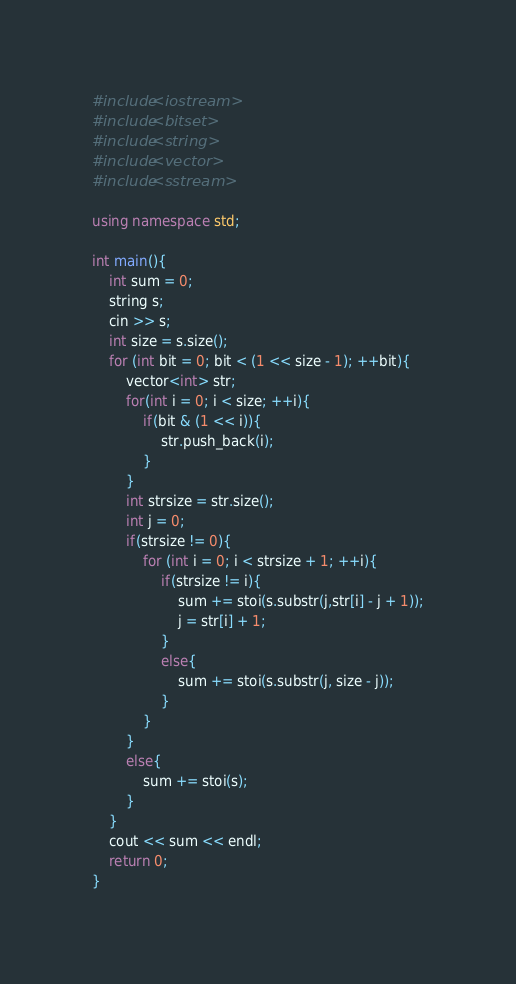Convert code to text. <code><loc_0><loc_0><loc_500><loc_500><_C++_>#include<iostream>
#include<bitset>
#include<string>
#include<vector>
#include<sstream>

using namespace std;

int main(){
    int sum = 0;
    string s;
    cin >> s;
    int size = s.size();
    for (int bit = 0; bit < (1 << size - 1); ++bit){
        vector<int> str;
        for(int i = 0; i < size; ++i){
            if(bit & (1 << i)){
                str.push_back(i);
            }
        }
        int strsize = str.size();
        int j = 0;
        if(strsize != 0){
            for (int i = 0; i < strsize + 1; ++i){
                if(strsize != i){
                    sum += stoi(s.substr(j,str[i] - j + 1));
                    j = str[i] + 1;
                }
                else{
                    sum += stoi(s.substr(j, size - j));
                }
            }
        }
        else{
            sum += stoi(s);
        }
    }
    cout << sum << endl;
    return 0;
}



</code> 